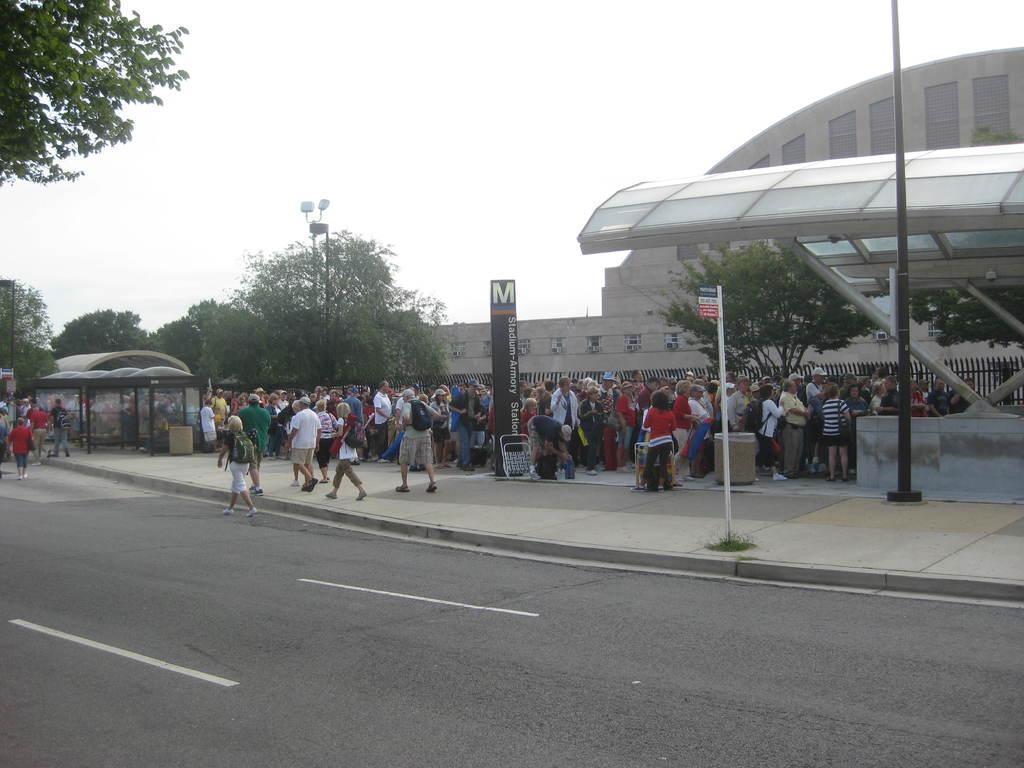In one or two sentences, can you explain what this image depicts? In this image in the center there are group of people walking and some of them are standing, at the bottom there is road and in the background there are trees, buildings. On the right side there are poles and building. And at the top there is sky and some dustbins. 